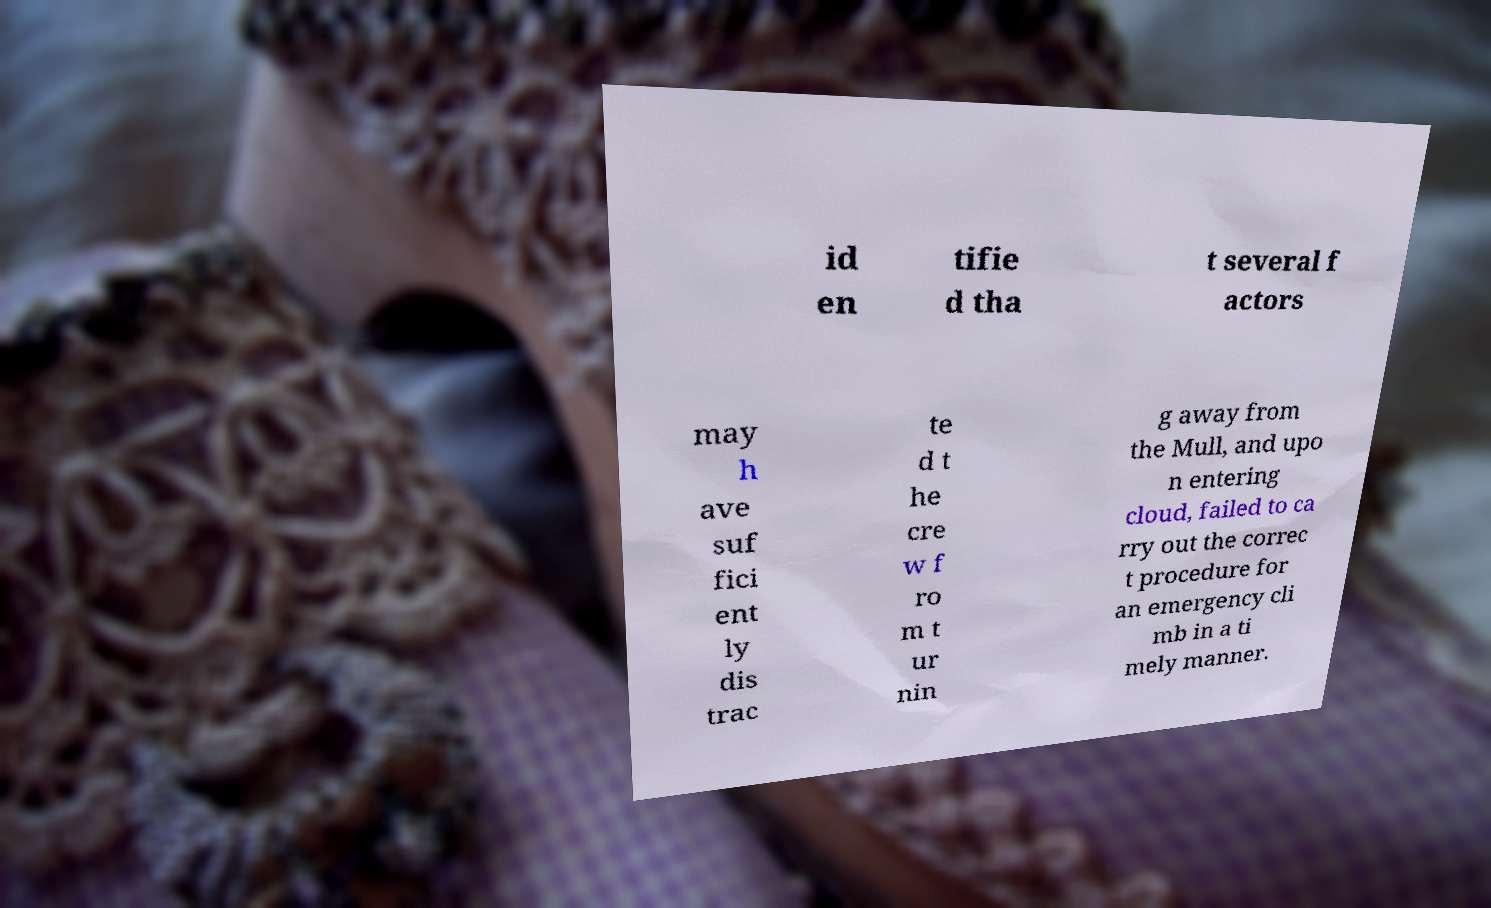There's text embedded in this image that I need extracted. Can you transcribe it verbatim? id en tifie d tha t several f actors may h ave suf fici ent ly dis trac te d t he cre w f ro m t ur nin g away from the Mull, and upo n entering cloud, failed to ca rry out the correc t procedure for an emergency cli mb in a ti mely manner. 